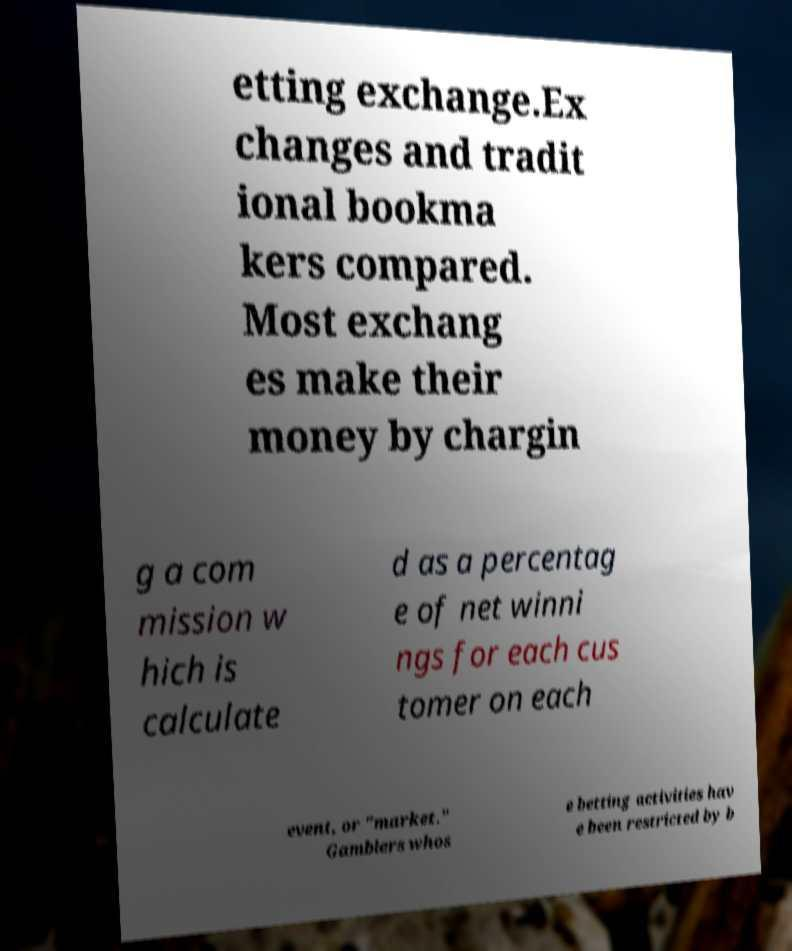I need the written content from this picture converted into text. Can you do that? etting exchange.Ex changes and tradit ional bookma kers compared. Most exchang es make their money by chargin g a com mission w hich is calculate d as a percentag e of net winni ngs for each cus tomer on each event, or "market." Gamblers whos e betting activities hav e been restricted by b 